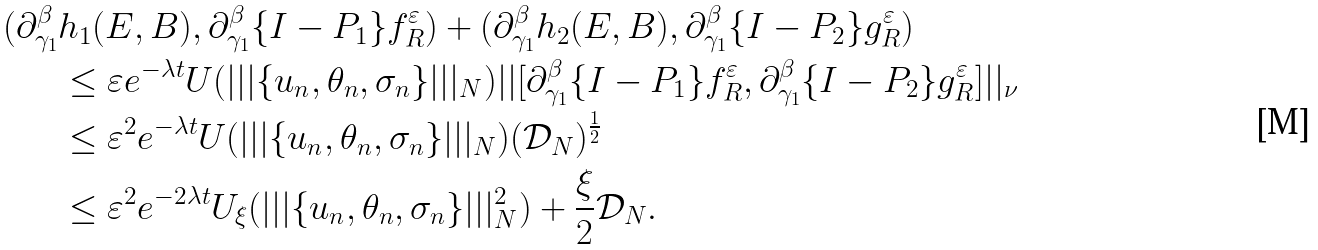<formula> <loc_0><loc_0><loc_500><loc_500>( \partial _ { \gamma _ { 1 } } ^ { \beta } & h _ { 1 } ( E , B ) , \partial _ { \gamma _ { 1 } } ^ { \beta } \{ I - P _ { 1 } \} f _ { R } ^ { \varepsilon } ) + ( \partial _ { \gamma _ { 1 } } ^ { \beta } h _ { 2 } ( E , B ) , \partial _ { \gamma _ { 1 } } ^ { \beta } \{ I - P _ { 2 } \} g _ { R } ^ { \varepsilon } ) \\ & \leq \varepsilon e ^ { - \lambda t } U ( | | | \{ u _ { n } , \theta _ { n } , \sigma _ { n } \} | | | _ { N } ) | | [ \partial _ { \gamma _ { 1 } } ^ { \beta } { \{ I - P _ { 1 } \} f _ { R } ^ { \varepsilon } } , \partial _ { \gamma _ { 1 } } ^ { \beta } { \{ I - P _ { 2 } \} g _ { R } ^ { \varepsilon } } ] | | _ { \nu } \\ & \leq \varepsilon ^ { 2 } e ^ { - \lambda t } U ( | | | \{ u _ { n } , \theta _ { n } , \sigma _ { n } \} | | | _ { N } ) ( \mathcal { D } _ { N } ) ^ { \frac { 1 } { 2 } } \\ & \leq \varepsilon ^ { 2 } e ^ { - 2 \lambda t } U _ { \xi } ( | | | \{ u _ { n } , \theta _ { n } , \sigma _ { n } \} | | | _ { N } ^ { 2 } ) + \frac { \xi } { 2 } \mathcal { D } _ { N } .</formula> 